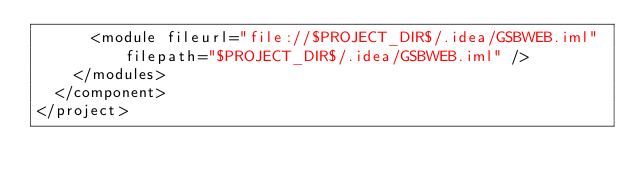<code> <loc_0><loc_0><loc_500><loc_500><_XML_>      <module fileurl="file://$PROJECT_DIR$/.idea/GSBWEB.iml" filepath="$PROJECT_DIR$/.idea/GSBWEB.iml" />
    </modules>
  </component>
</project></code> 